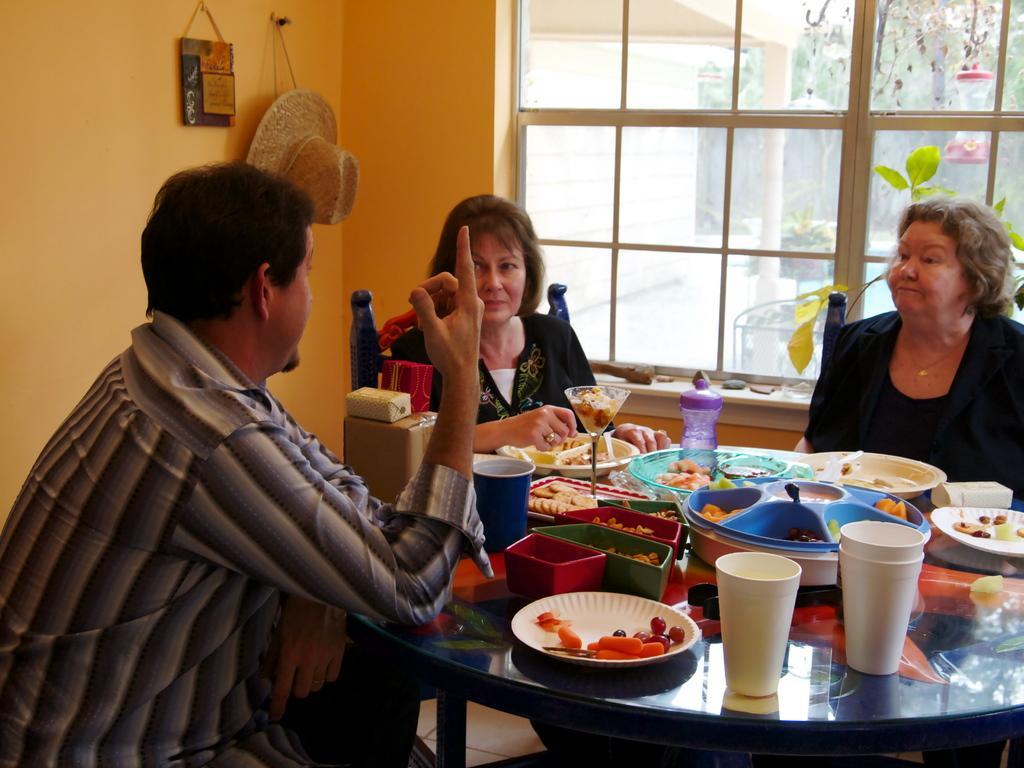How would you summarize this image in a sentence or two? In the middle there is a table with lots of food items ,plates,cups ,bottle. Three people are sitting in front of table. On the left there is a man he is wearing shirt. in the middle there is a woman she is wearing a dress. in the left there is a woman her hair is small. In the left there is a plant and leaf. In the middle there is window with glass. I think this is a house. In the left there is a hat. In the leaf there is a wall. 